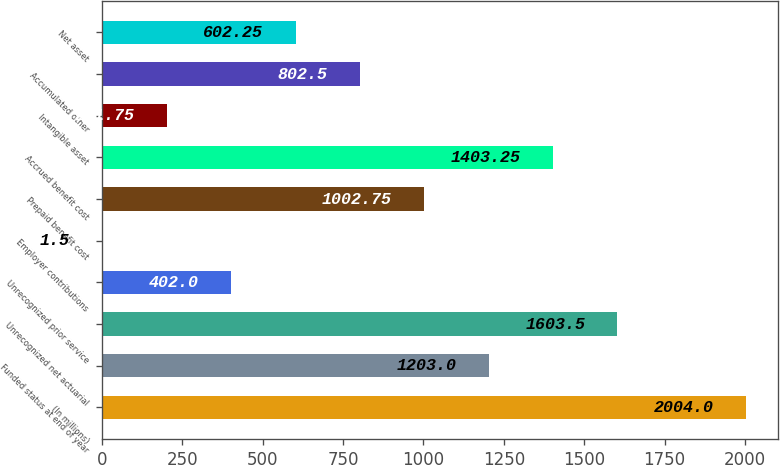<chart> <loc_0><loc_0><loc_500><loc_500><bar_chart><fcel>(In millions)<fcel>Funded status at end of year<fcel>Unrecognized net actuarial<fcel>Unrecognized prior service<fcel>Employer contributions<fcel>Prepaid benefit cost<fcel>Accrued benefit cost<fcel>Intangible asset<fcel>Accumulated other<fcel>Net asset<nl><fcel>2004<fcel>1203<fcel>1603.5<fcel>402<fcel>1.5<fcel>1002.75<fcel>1403.25<fcel>201.75<fcel>802.5<fcel>602.25<nl></chart> 